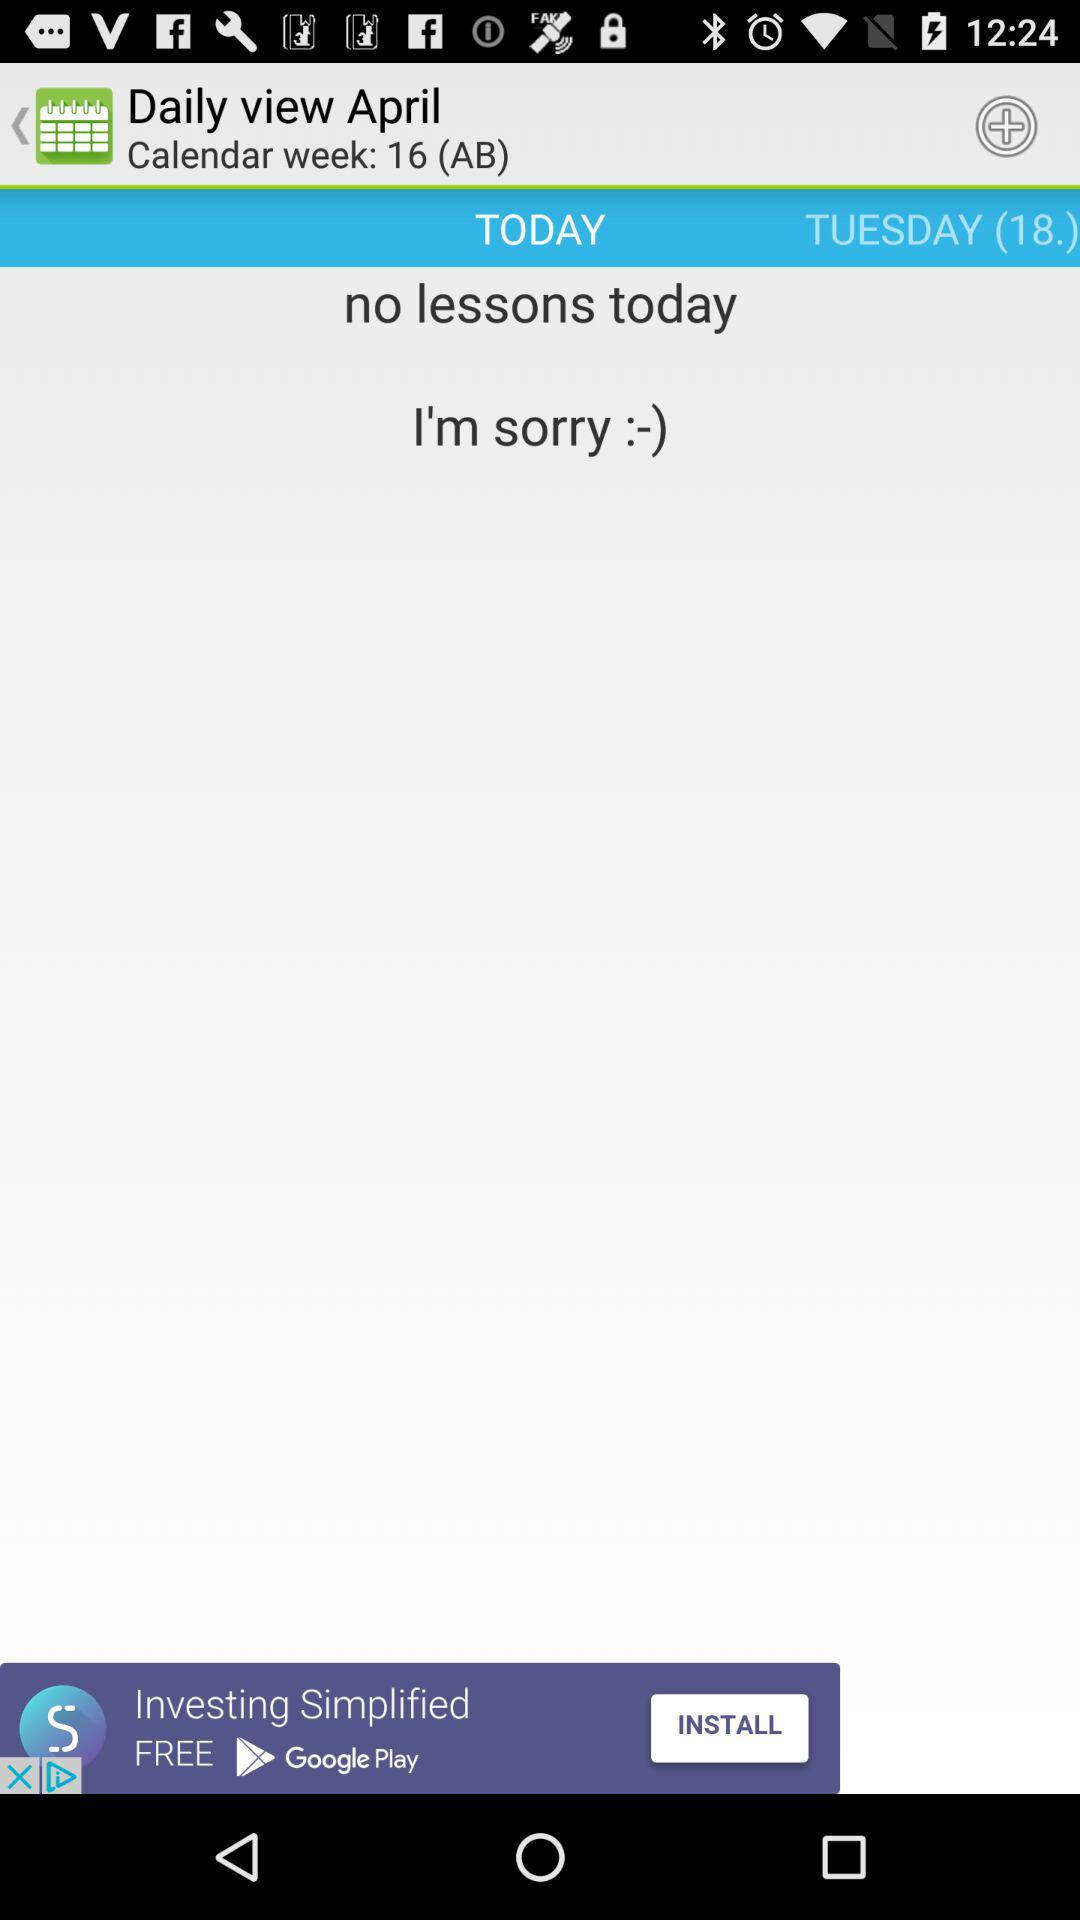How many lessons are there today?
Answer the question using a single word or phrase. 0 